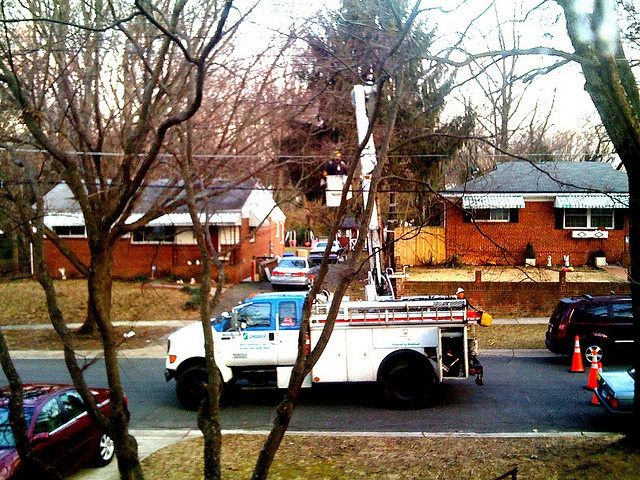Describe the objects in this image and their specific colors. I can see truck in white, black, darkgray, and gray tones, car in white, black, maroon, and gray tones, car in white, black, navy, maroon, and gray tones, car in white, black, lightblue, and navy tones, and car in white, black, gray, and darkgray tones in this image. 